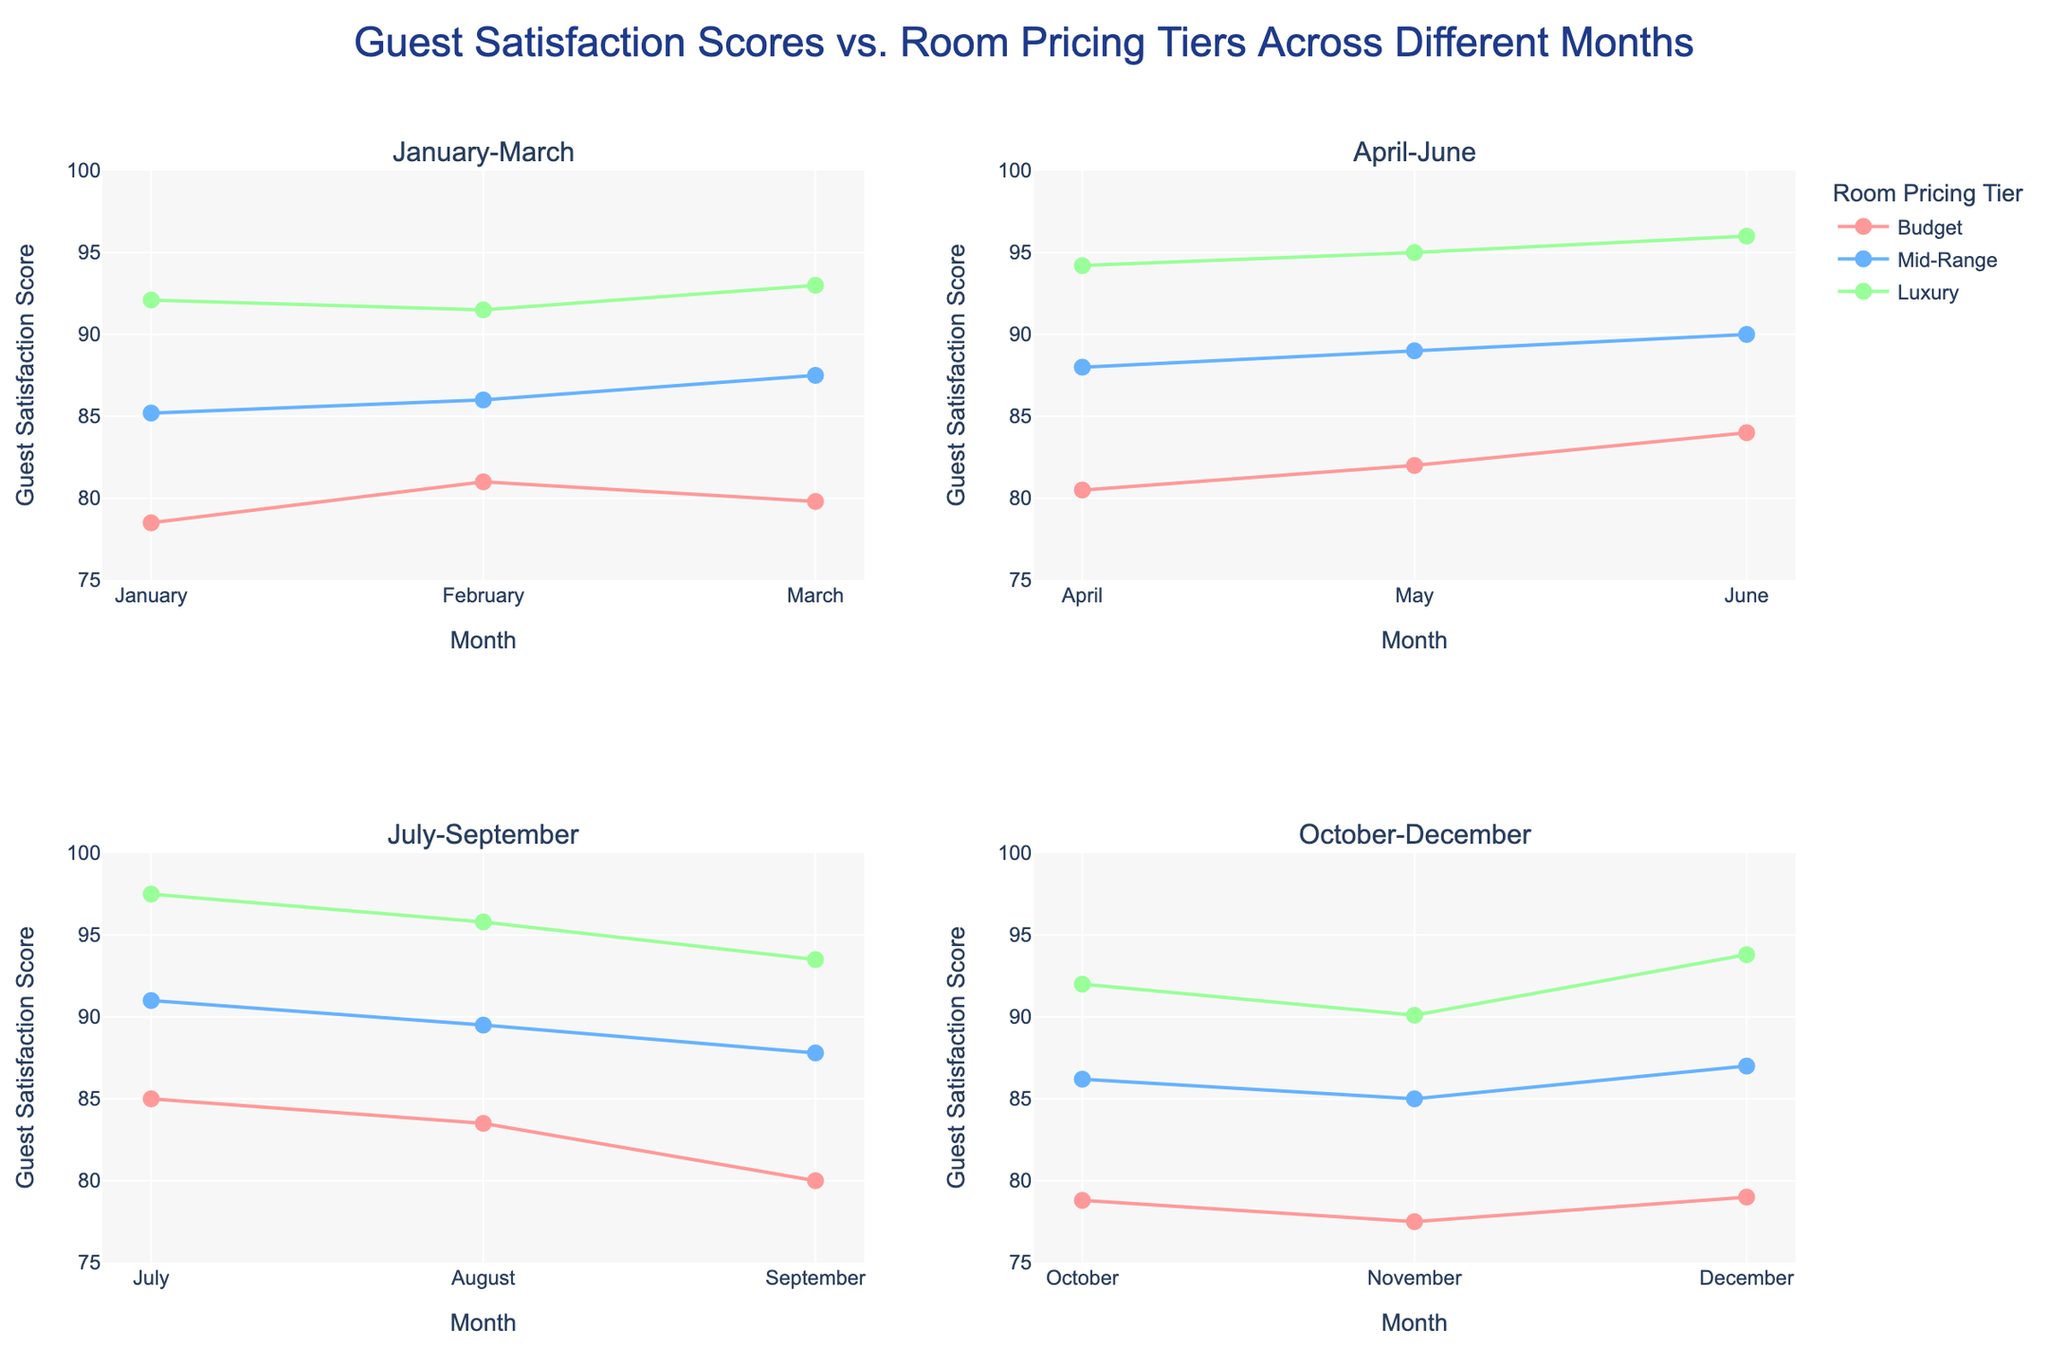What is the title of the figure? The title of the figure is displayed at the top and indicates what the chart is about. This helps in understanding the overall content of the graphs.
Answer: Guest Satisfaction Scores vs. Room Pricing Tiers Across Different Months What months are covered in the bottom left subplot? The bottom left subplot is for the third quarter of the year, covering the months from July to September. This is visible from the axis labels on that subplot.
Answer: July, August, and September Which room pricing tier has the highest guest satisfaction scores across all subplots? Across all subplots, the luxury tier consistently shows the highest guest satisfaction scores when comparing the data points and lines for each month. This is observed by looking at the position of the highest data points in each subplot.
Answer: Luxury What is the range of guest satisfaction scores for the budget tier in the top right subplot? The top right subplot covers April to June. For the budget tier, you can see the data points and their corresponding values in the figure, which range from approximately 80.5 to 84.0.
Answer: 80.5 to 84.0 In which month does the mid-range tier show the highest guest satisfaction score? By comparing the guest satisfaction scores of the mid-range tier across all subplots and months, July shows the highest guest satisfaction score with a value of 91.0. This is the peak point for the mid-range series.
Answer: July How does the trend of guest satisfaction scores for the budget tier change from January to December? Observing the data points for the budget tier across all months, there's a noticeable overall increase in guest satisfaction scores from 78.5 in January to a peak around 85.0 in July, with a slight decline thereafter toward December at 79.0.
Answer: Increases initially, peaks, then declines What is the average guest satisfaction score for the luxury tier in the bottom right subplot? The bottom right subplot covers October to December. Averaging the luxury tier scores (92.0, 90.1, 93.8) requires summing these values (275.9) and dividing by the number of months (3), equaling approximately 92.0.
Answer: 92.0 Compare the trend of the guest satisfaction scores for the mid-range tier in the first and second subplots. The first subplot (January-March) shows a generally increasing trend for the mid-range tier, starting at 85.2 in January and reaching 87.5 in March. The second subplot (April-June) continues this upward trend from 88.0 in April to 90.0 in June. In both cases, the trend is upward.
Answer: Both show an increasing trend Which quarter shows the greatest increase in guest satisfaction scores for the budget tier? By comparing the data points for each quarter, the second quarter (April-June) shows the greatest increase, from 80.5 in April to 84.0 in June. This can be concluded by looking at the slope of the lines representing the budget tier in each subplot.
Answer: Second quarter (April-June) 